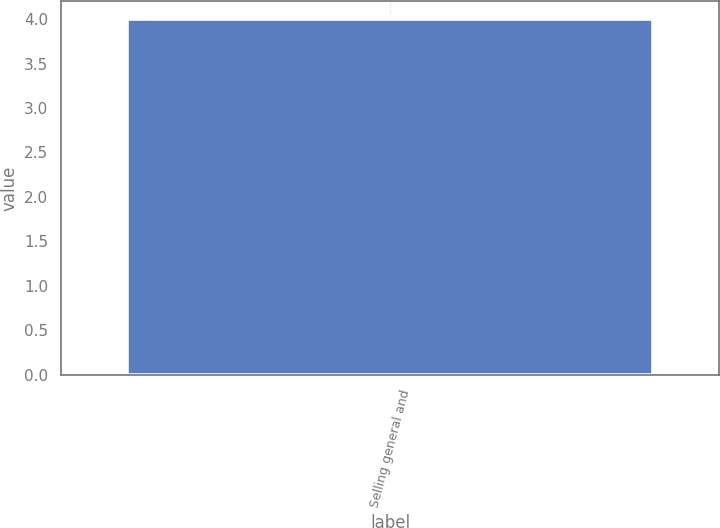Convert chart. <chart><loc_0><loc_0><loc_500><loc_500><bar_chart><fcel>Selling general and<nl><fcel>4<nl></chart> 